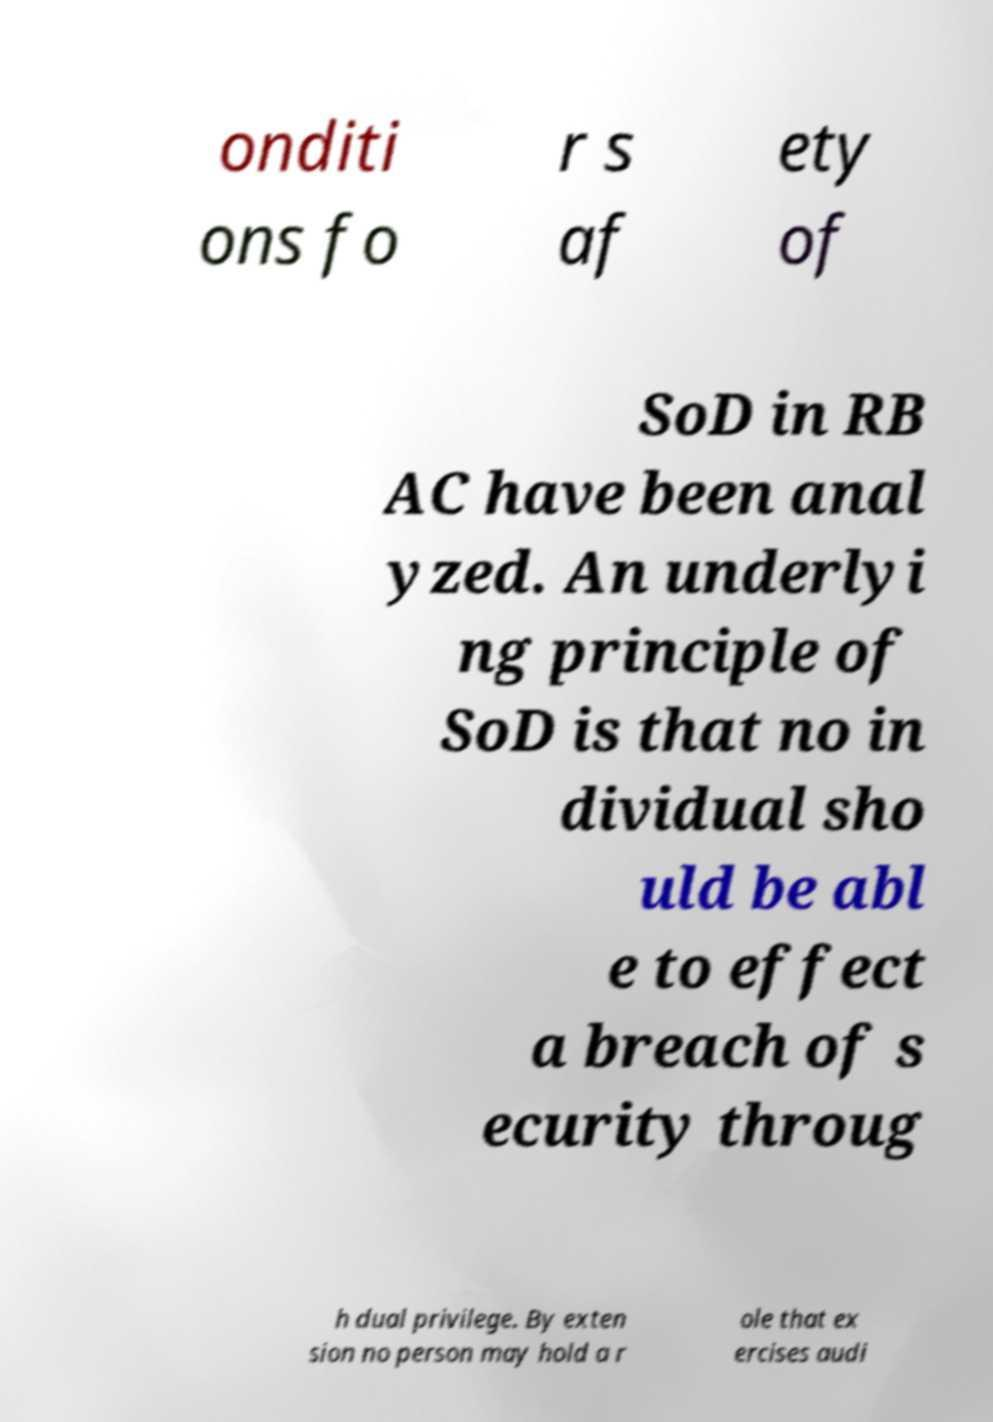What messages or text are displayed in this image? I need them in a readable, typed format. onditi ons fo r s af ety of SoD in RB AC have been anal yzed. An underlyi ng principle of SoD is that no in dividual sho uld be abl e to effect a breach of s ecurity throug h dual privilege. By exten sion no person may hold a r ole that ex ercises audi 